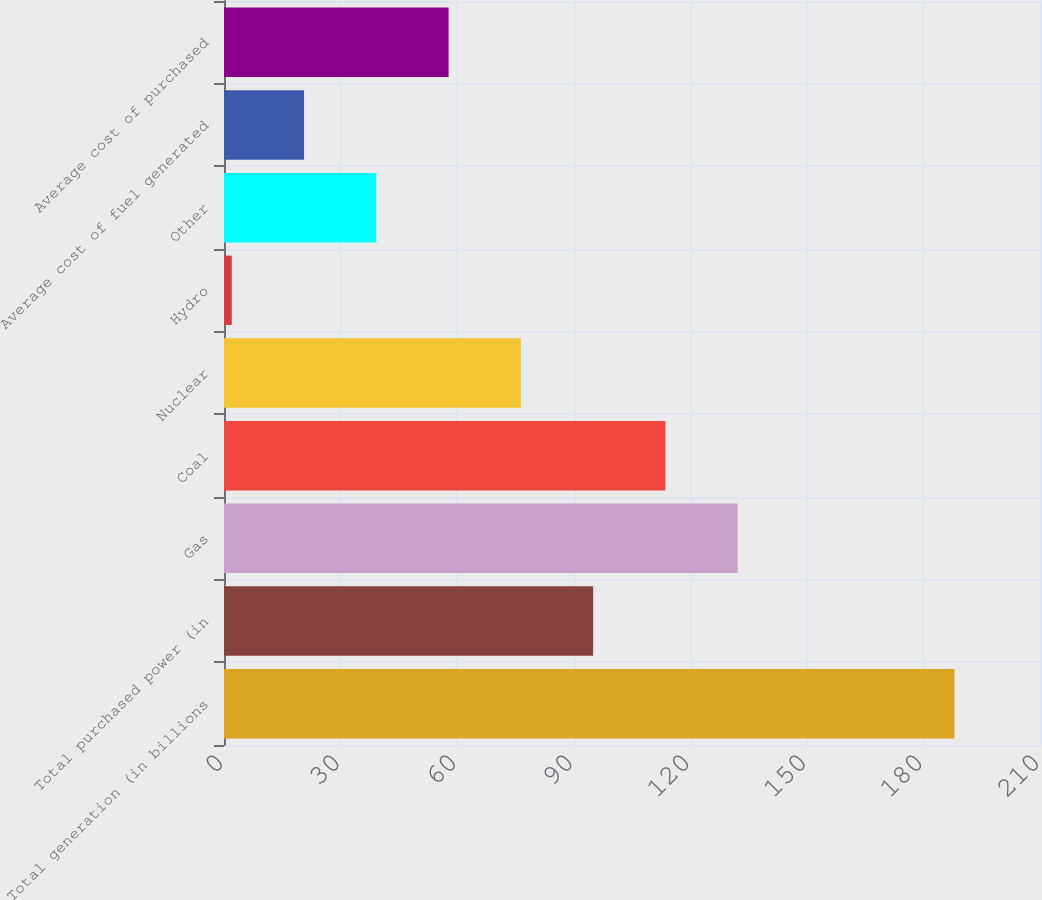Convert chart. <chart><loc_0><loc_0><loc_500><loc_500><bar_chart><fcel>Total generation (in billions<fcel>Total purchased power (in<fcel>Gas<fcel>Coal<fcel>Nuclear<fcel>Hydro<fcel>Other<fcel>Average cost of fuel generated<fcel>Average cost of purchased<nl><fcel>188<fcel>95<fcel>132.2<fcel>113.6<fcel>76.4<fcel>2<fcel>39.2<fcel>20.6<fcel>57.8<nl></chart> 